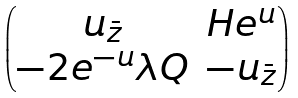Convert formula to latex. <formula><loc_0><loc_0><loc_500><loc_500>\begin{pmatrix} u _ { \bar { z } } & H e ^ { u } \\ - 2 e ^ { - u } \lambda Q & - u _ { \bar { z } } \end{pmatrix}</formula> 